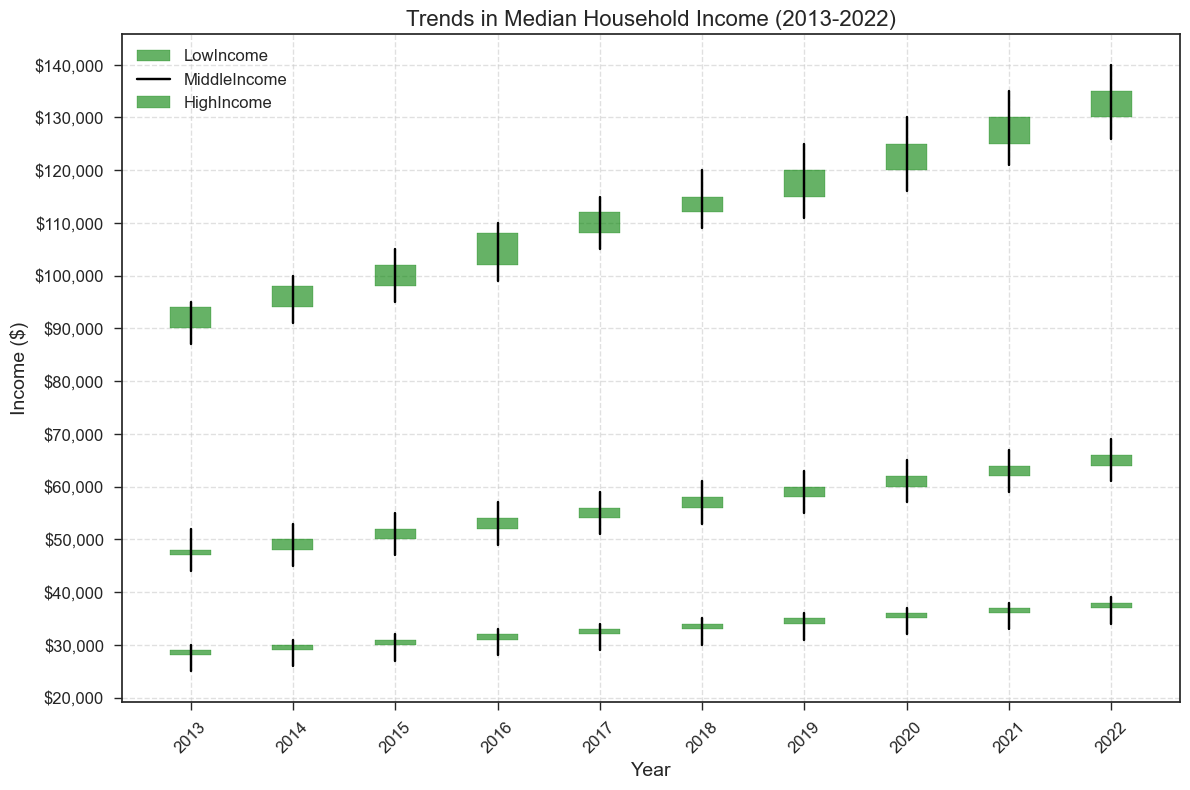Which group had the highest median household income in 2022? Looking at the last datapoint for each group in 2022, the HighIncome group clearly has the highest median income as indicated by the highest closing value.
Answer: HighIncome Between LowIncome and MiddleIncome groups, which had a greater increase in median income from 2013 to 2022? To find the increase, subtract the 2013 closing value from the 2022 closing value for each group. For LowIncome, that's 38000 - 29000 = 9000. For MiddleIncome, that's 66000 - 48000 = 18000. Comparing these, MiddleIncome had a greater increase.
Answer: MiddleIncome What is the total range of median household income across all groups and years shown? The total range is determined by the highest high and the lowest low across all groups and years. The highest high is 140000 (HighIncome in 2022) and the lowest low is 25000 (LowIncome in 2013), so the range is 140000 - 25000 = 115000.
Answer: 115000 Which group showed the most consistent growth in median household income over the years 2013-2022? Look at the trend of closing values. The HighIncome group has a steady upward trend without any drops, indicating consistent growth.
Answer: HighIncome In which year did the MiddleIncome group experience the highest volatility in median household income? Volatility can be assessed by the difference between the high and low values within a year. For MiddleIncome, 2016 has the highest difference: 57000 (High) - 49000 (Low) = 8000.
Answer: 2016 